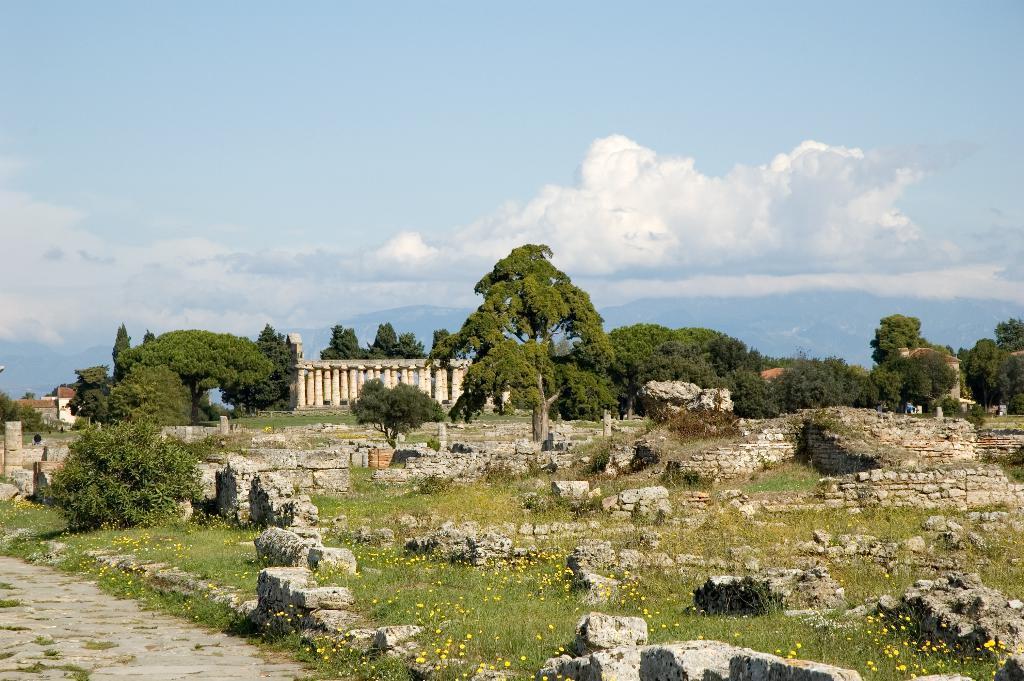In one or two sentences, can you explain what this image depicts? Here in this picture we can see number of rock stone walls present on the ground, which is fully covered with grass over there and we can see plants and trees present all over there and in the far we can see pillars present and we can see clouds in the sky. 